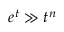<formula> <loc_0><loc_0><loc_500><loc_500>e ^ { t } \gg t ^ { n }</formula> 